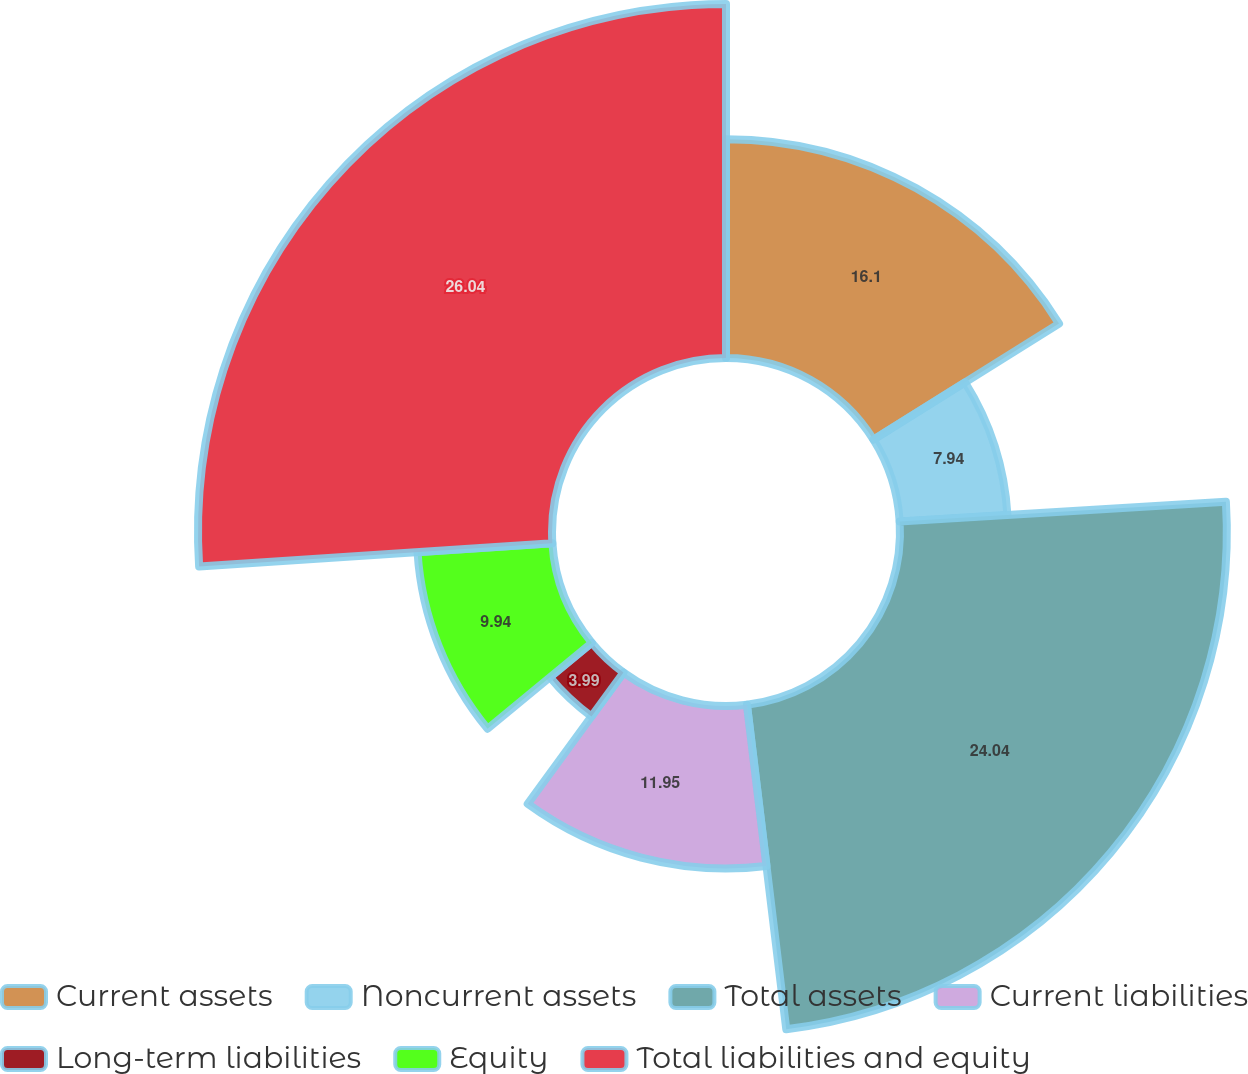Convert chart to OTSL. <chart><loc_0><loc_0><loc_500><loc_500><pie_chart><fcel>Current assets<fcel>Noncurrent assets<fcel>Total assets<fcel>Current liabilities<fcel>Long-term liabilities<fcel>Equity<fcel>Total liabilities and equity<nl><fcel>16.1%<fcel>7.94%<fcel>24.04%<fcel>11.95%<fcel>3.99%<fcel>9.94%<fcel>26.04%<nl></chart> 